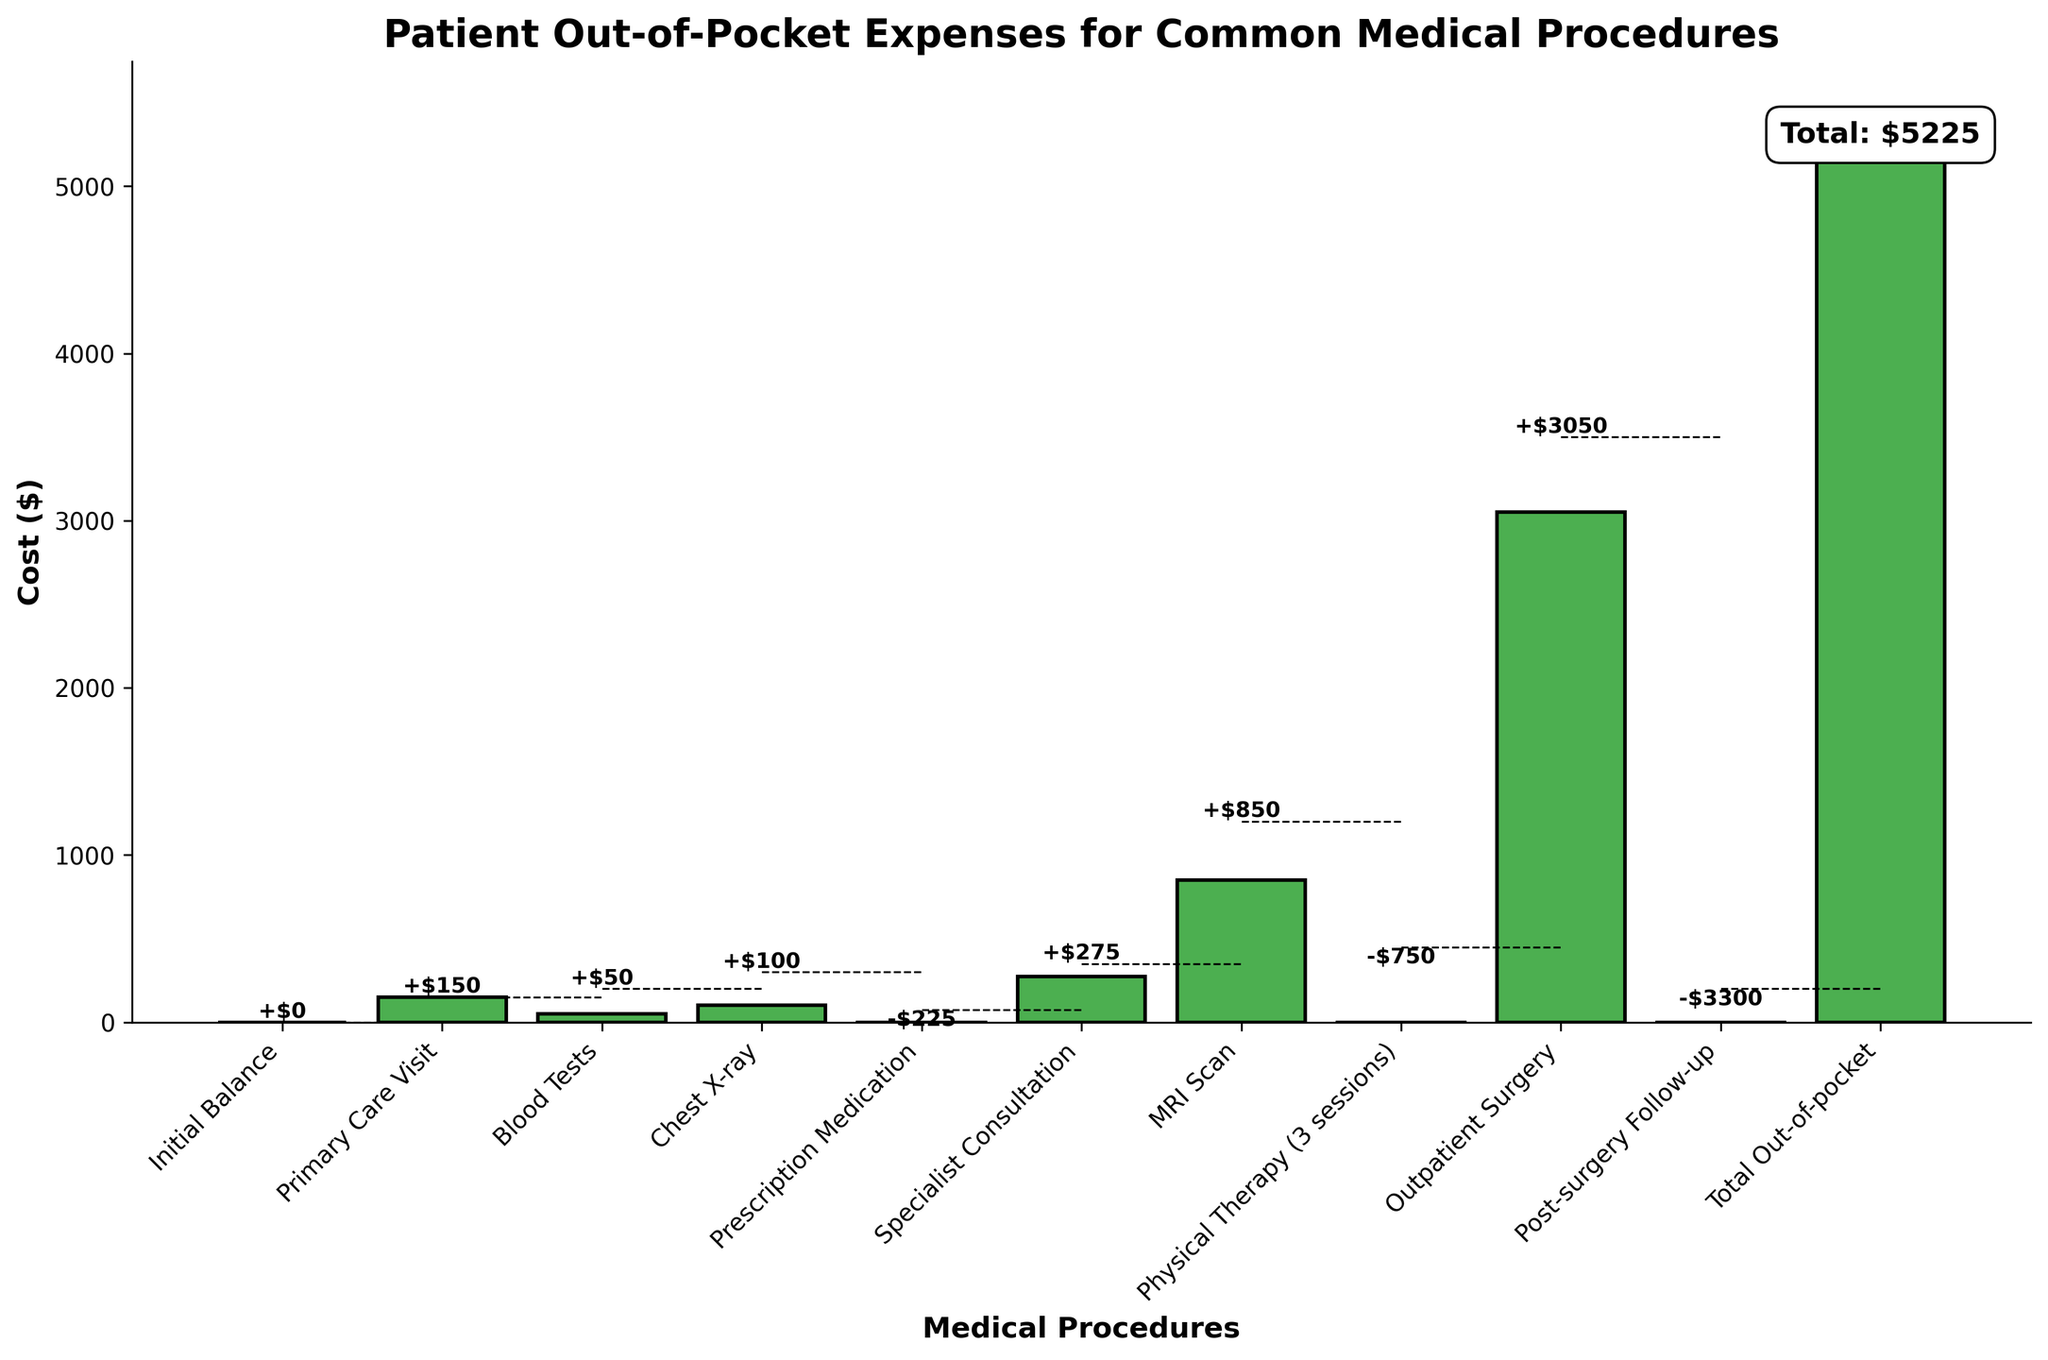What is the title of the figure? The title of the figure is displayed at the top. It states "Patient Out-of-Pocket Expenses for Common Medical Procedures".
Answer: Patient Out-of-Pocket Expenses for Common Medical Procedures What is the cost of the MRI Scan? The cost of the MRI Scan is denoted on the respective bar on the figure. The value indicated is $1200.
Answer: $1200 Which procedure has the largest increase in cost? By comparing the height of the bars representing cost changes, the Outpatient Surgery bar is the tallest, indicating the largest increase.
Answer: Outpatient Surgery What is the total cost after the Post-surgery Follow-up? The value just after the Post-surgery Follow-up bar shows the cost at that stage. The value is $3500. Subtracting the $3300 change gives us $200.
Answer: $200 What was the cost change due to Physical Therapy? The Physical Therapy bar has a downward bar indicating a negative change. The specific change shown on the bar is -$750.
Answer: -$750 What is the sum of cost changes for procedures that decreased the total cost? Identify the procedures with negative changes (Prescription Medication, Physical Therapy, and Post-surgery Follow-up). Add these changes: -$225 + -$750 + -$3300 = -$4275.
Answer: -$4275 Compare the cost change of the Specialist Consultation and the Blood Tests. Which one had a higher increase? Specialist Consultation had a cost change of $275, and Blood Tests had $50. Comparing these, $275 is greater than $50.
Answer: Specialist Consultation Which expense made the highest single increase in the total out-of-pocket cost? The tallest bar on the chart indicates the highest increase. Outpatient Surgery makes the highest increase of $3050.
Answer: Outpatient Surgery Which procedures resulted in a cost reduction in the out-of-pocket expenses? Identify the procedures with negative changes by observing the downward bars: Prescription Medication, Physical Therapy, and Post-surgery Follow-up.
Answer: Prescription Medication, Physical Therapy, Post-surgery Follow-up What is the total out-of-pocket expense at the end of all procedures? The last bar titled "Total Out-of-pocket" indicates the total expense. The value shown is $5225.
Answer: $5225 